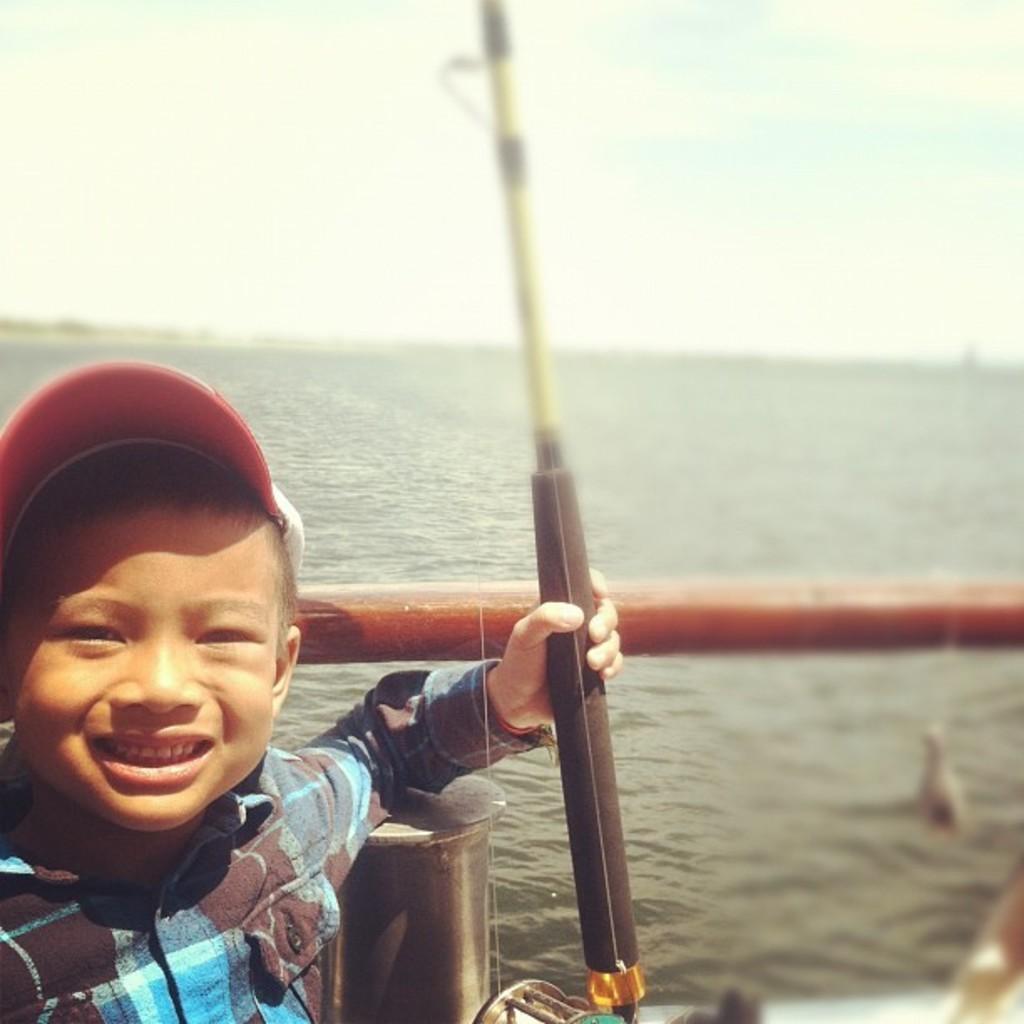Could you give a brief overview of what you see in this image? A little boy is smiling, he wore a shirt, cap. This is water, at the top it's a sky. 